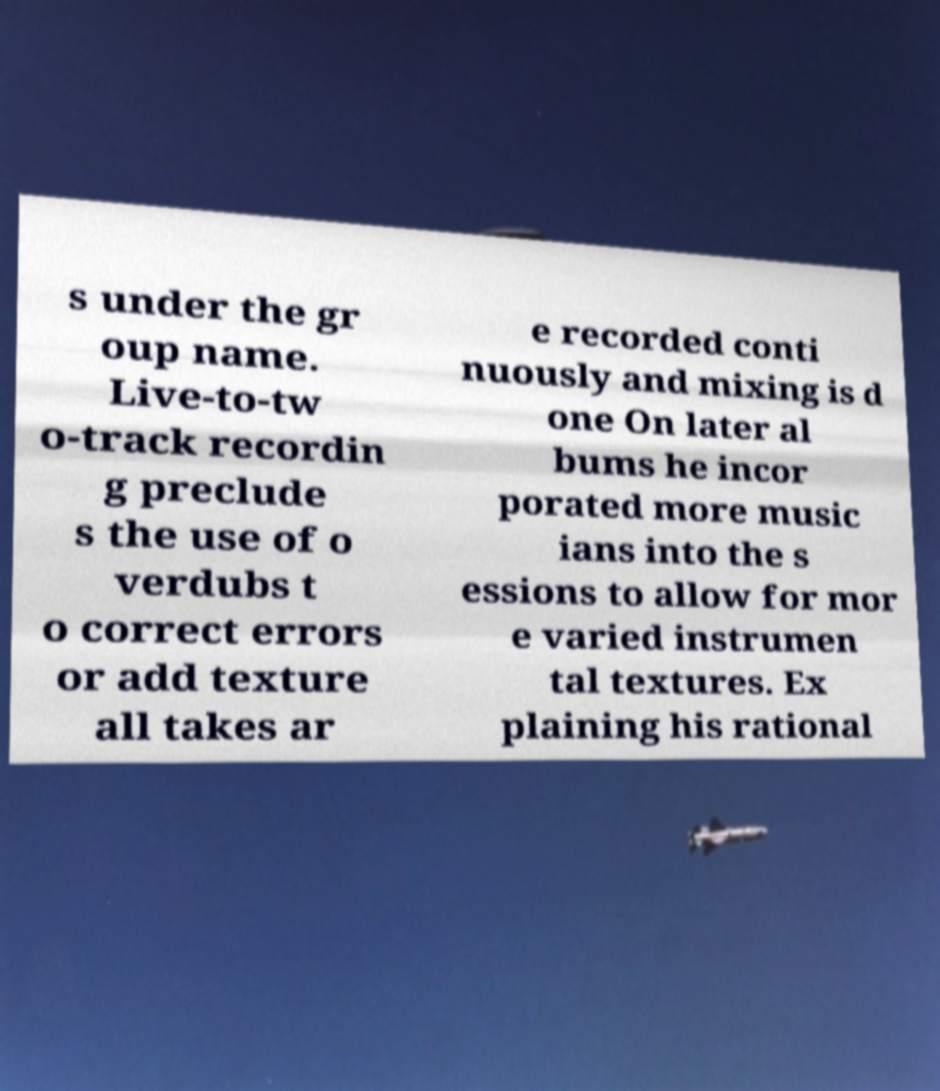Can you read and provide the text displayed in the image?This photo seems to have some interesting text. Can you extract and type it out for me? s under the gr oup name. Live-to-tw o-track recordin g preclude s the use of o verdubs t o correct errors or add texture all takes ar e recorded conti nuously and mixing is d one On later al bums he incor porated more music ians into the s essions to allow for mor e varied instrumen tal textures. Ex plaining his rational 